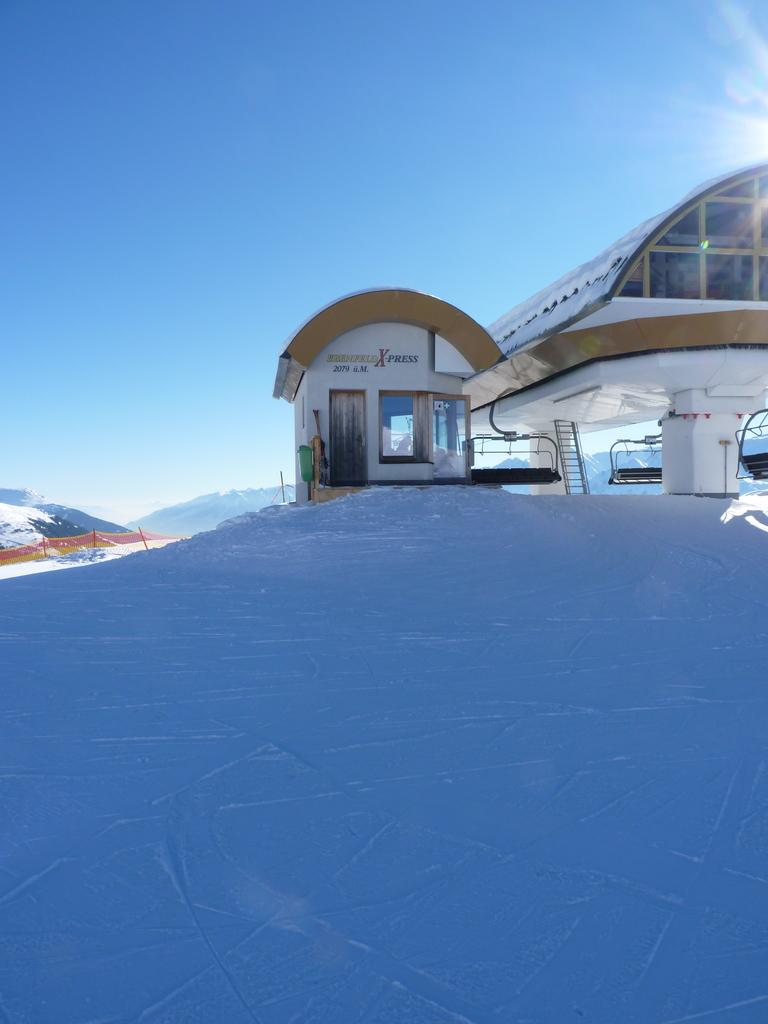What type of structure can be seen in the image? There is a wall in the image. Are there any openings in the wall? Yes, there is a door and windows in the image. What else is present in the image? There is a ladder and hills visible. What can be seen in the sky? The sky is visible in the image. What type of jeans is the group wearing in the image? There is no group of people present in the image, and therefore no jeans can be observed. What class is being taught in the image? There is no class or educational setting depicted in the image. 